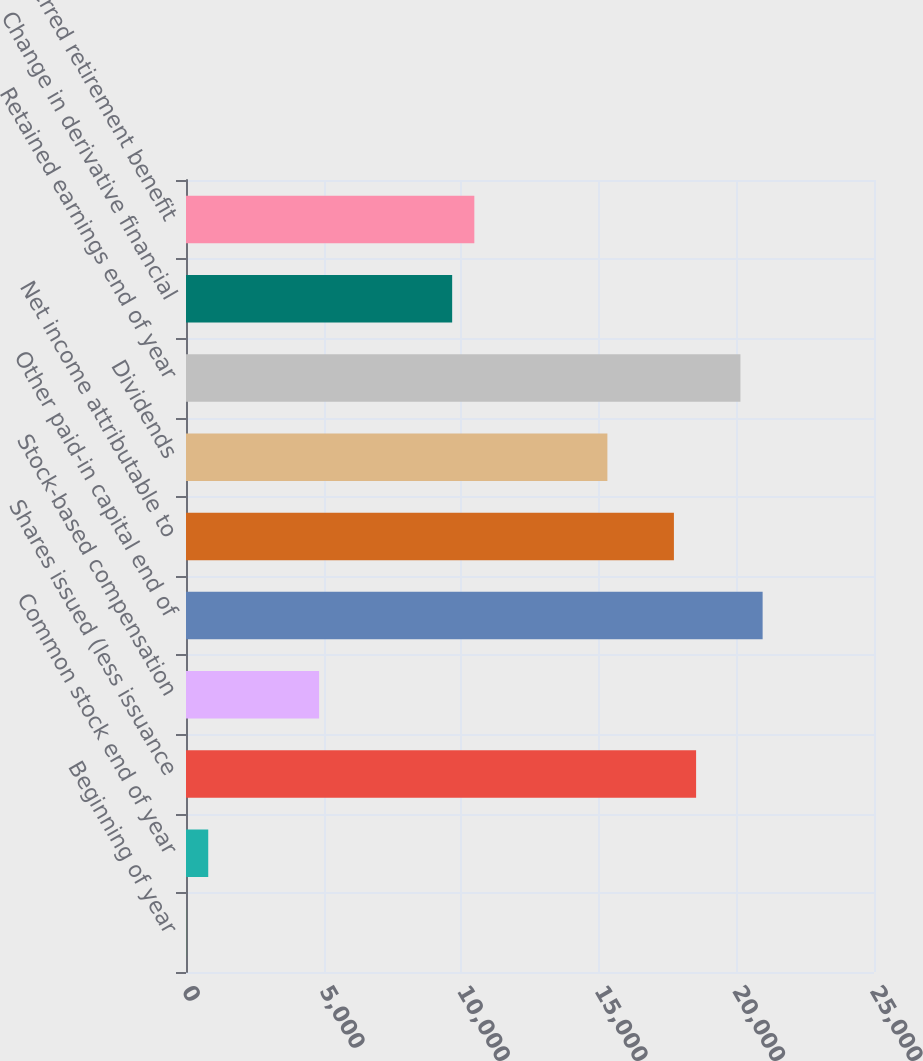Convert chart to OTSL. <chart><loc_0><loc_0><loc_500><loc_500><bar_chart><fcel>Beginning of year<fcel>Common stock end of year<fcel>Shares issued (less issuance<fcel>Stock-based compensation<fcel>Other paid-in capital end of<fcel>Net income attributable to<fcel>Dividends<fcel>Retained earnings end of year<fcel>Change in derivative financial<fcel>Deferred retirement benefit<nl><fcel>2<fcel>807.8<fcel>18535.4<fcel>4836.8<fcel>20952.8<fcel>17729.6<fcel>15312.2<fcel>20147<fcel>9671.6<fcel>10477.4<nl></chart> 